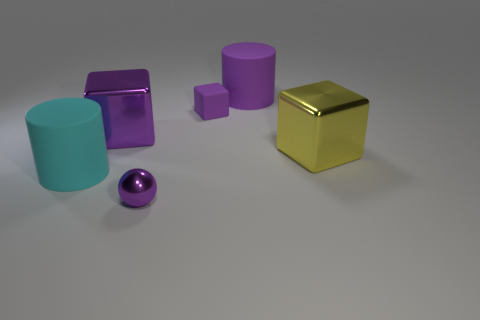Add 4 yellow metal objects. How many objects exist? 10 Subtract all cylinders. How many objects are left? 4 Subtract 1 yellow blocks. How many objects are left? 5 Subtract all large cyan matte objects. Subtract all large green matte objects. How many objects are left? 5 Add 1 large purple matte cylinders. How many large purple matte cylinders are left? 2 Add 5 large green blocks. How many large green blocks exist? 5 